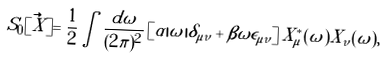Convert formula to latex. <formula><loc_0><loc_0><loc_500><loc_500>S _ { 0 } [ \vec { X } ] = \frac { 1 } { 2 } \int \frac { d \omega } { ( 2 \pi ) ^ { 2 } } \left [ \alpha | \omega | \delta _ { \mu \nu } + \beta \omega \epsilon _ { \mu \nu } \right ] X ^ { * } _ { \mu } ( \omega ) X _ { \nu } ( \omega ) ,</formula> 